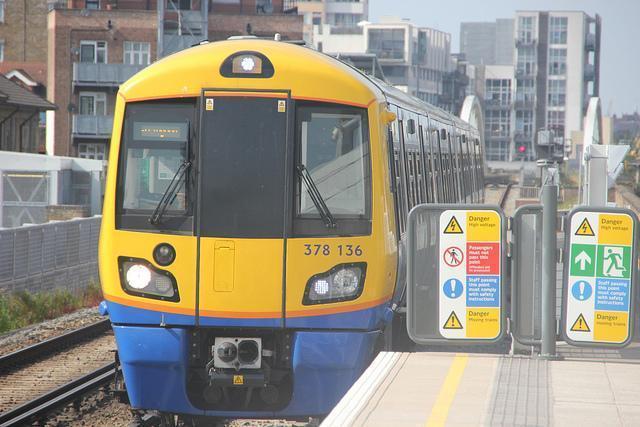How many warning signs?
Give a very brief answer. 2. How many people are holding tennis rackets in the image?
Give a very brief answer. 0. 